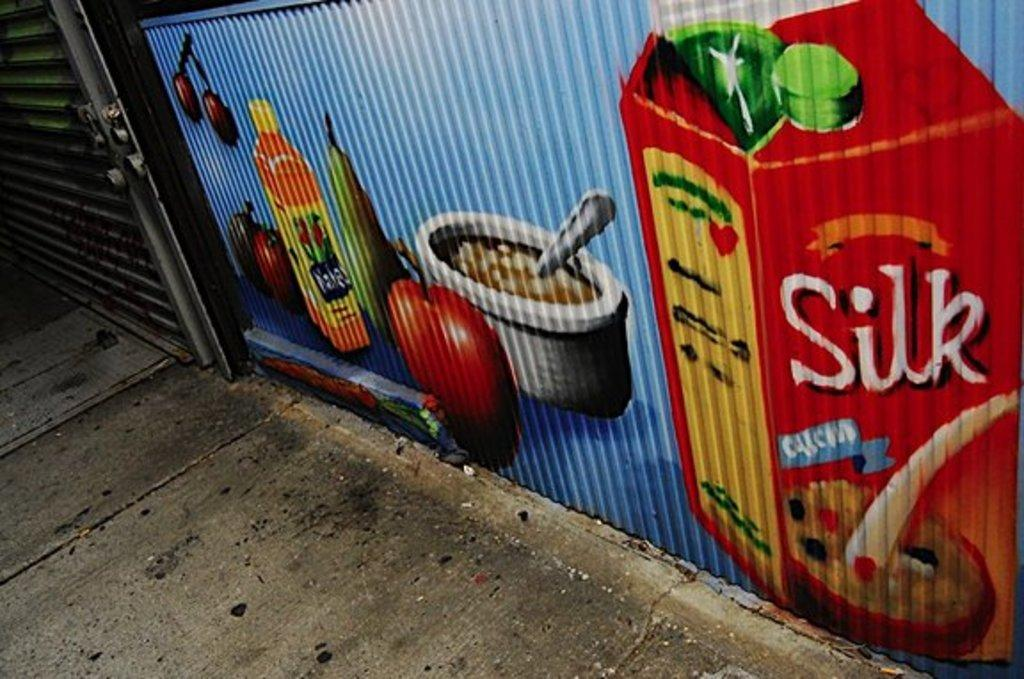What is depicted in the drawing in the image? There is a drawing of food packets in the image. What is in the bowl that is visible in the image? There is a bowl with food in the image. What type of food is on the metal sheet in the image? There are fruits on a metal sheet in the image. What is the door made of in the image? The door is made of metal in the image. What is used to secure the metal door in the image? There are locks on the metal door in the image. What can be seen beneath the objects in the image? The ground is visible in the image. How is the tax calculated for the food in the image? There is no mention of tax or any financial aspect in the image; it only shows food items and a drawing of food packets. What type of steam is coming out of the bowl in the image? There is no steam present in the image; the bowl contains food, but it is not steaming. 